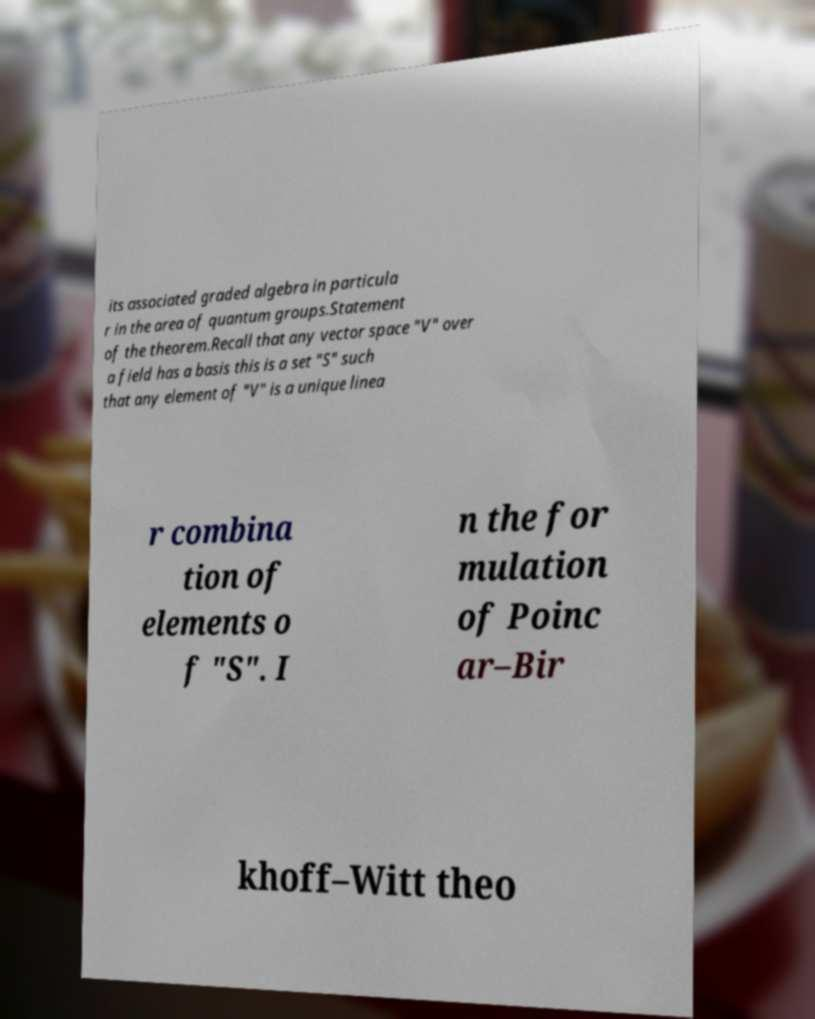Can you read and provide the text displayed in the image?This photo seems to have some interesting text. Can you extract and type it out for me? its associated graded algebra in particula r in the area of quantum groups.Statement of the theorem.Recall that any vector space "V" over a field has a basis this is a set "S" such that any element of "V" is a unique linea r combina tion of elements o f "S". I n the for mulation of Poinc ar–Bir khoff–Witt theo 